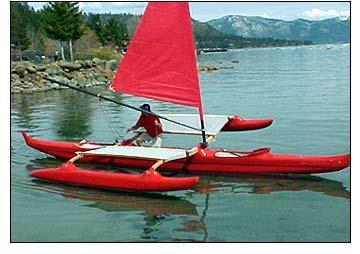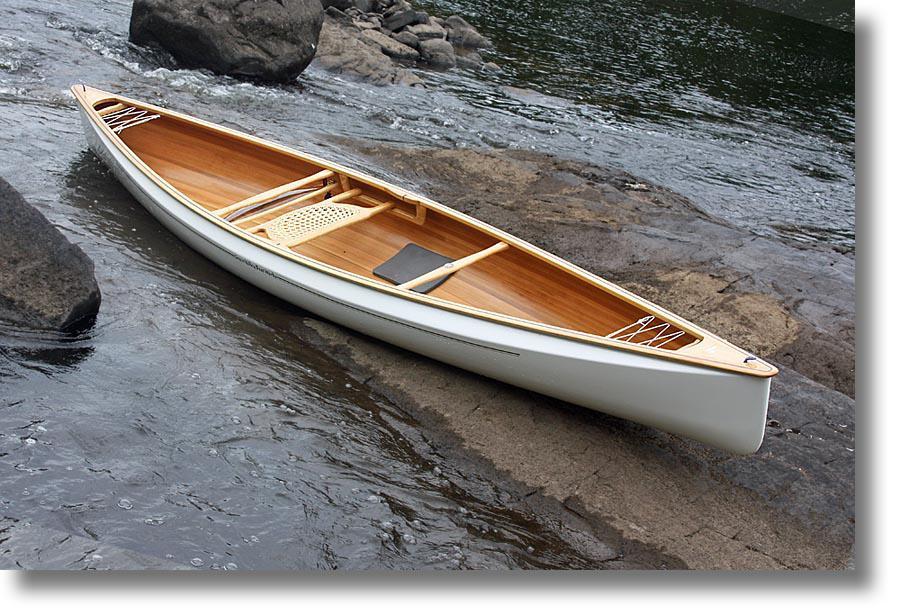The first image is the image on the left, the second image is the image on the right. Evaluate the accuracy of this statement regarding the images: "In one image, there is a white canoe resting slightly on its side on a large rocky area in the middle of a body of water". Is it true? Answer yes or no. Yes. The first image is the image on the left, the second image is the image on the right. Assess this claim about the two images: "One image shows a person on a boat in the water, and the other image shows a white canoe pulled up out of the water near gray boulders.". Correct or not? Answer yes or no. Yes. 